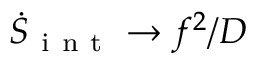Convert formula to latex. <formula><loc_0><loc_0><loc_500><loc_500>\dot { S } _ { i n t } \rightarrow f ^ { 2 } / D</formula> 